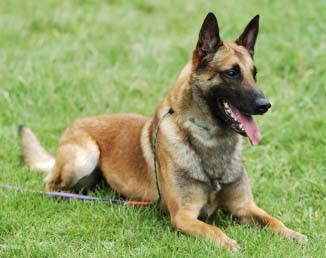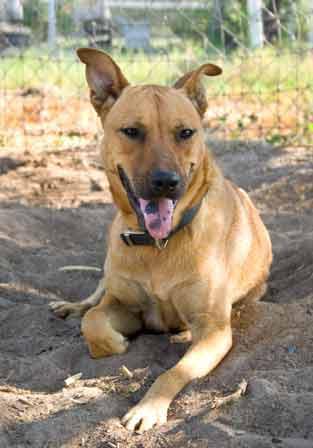The first image is the image on the left, the second image is the image on the right. Considering the images on both sides, is "There is a human touching one of the dogs." valid? Answer yes or no. No. The first image is the image on the left, the second image is the image on the right. Examine the images to the left and right. Is the description "One dog with a dark muzzle is reclining on the grass, and at least one dog has an opened, non-snarling mouth." accurate? Answer yes or no. Yes. 